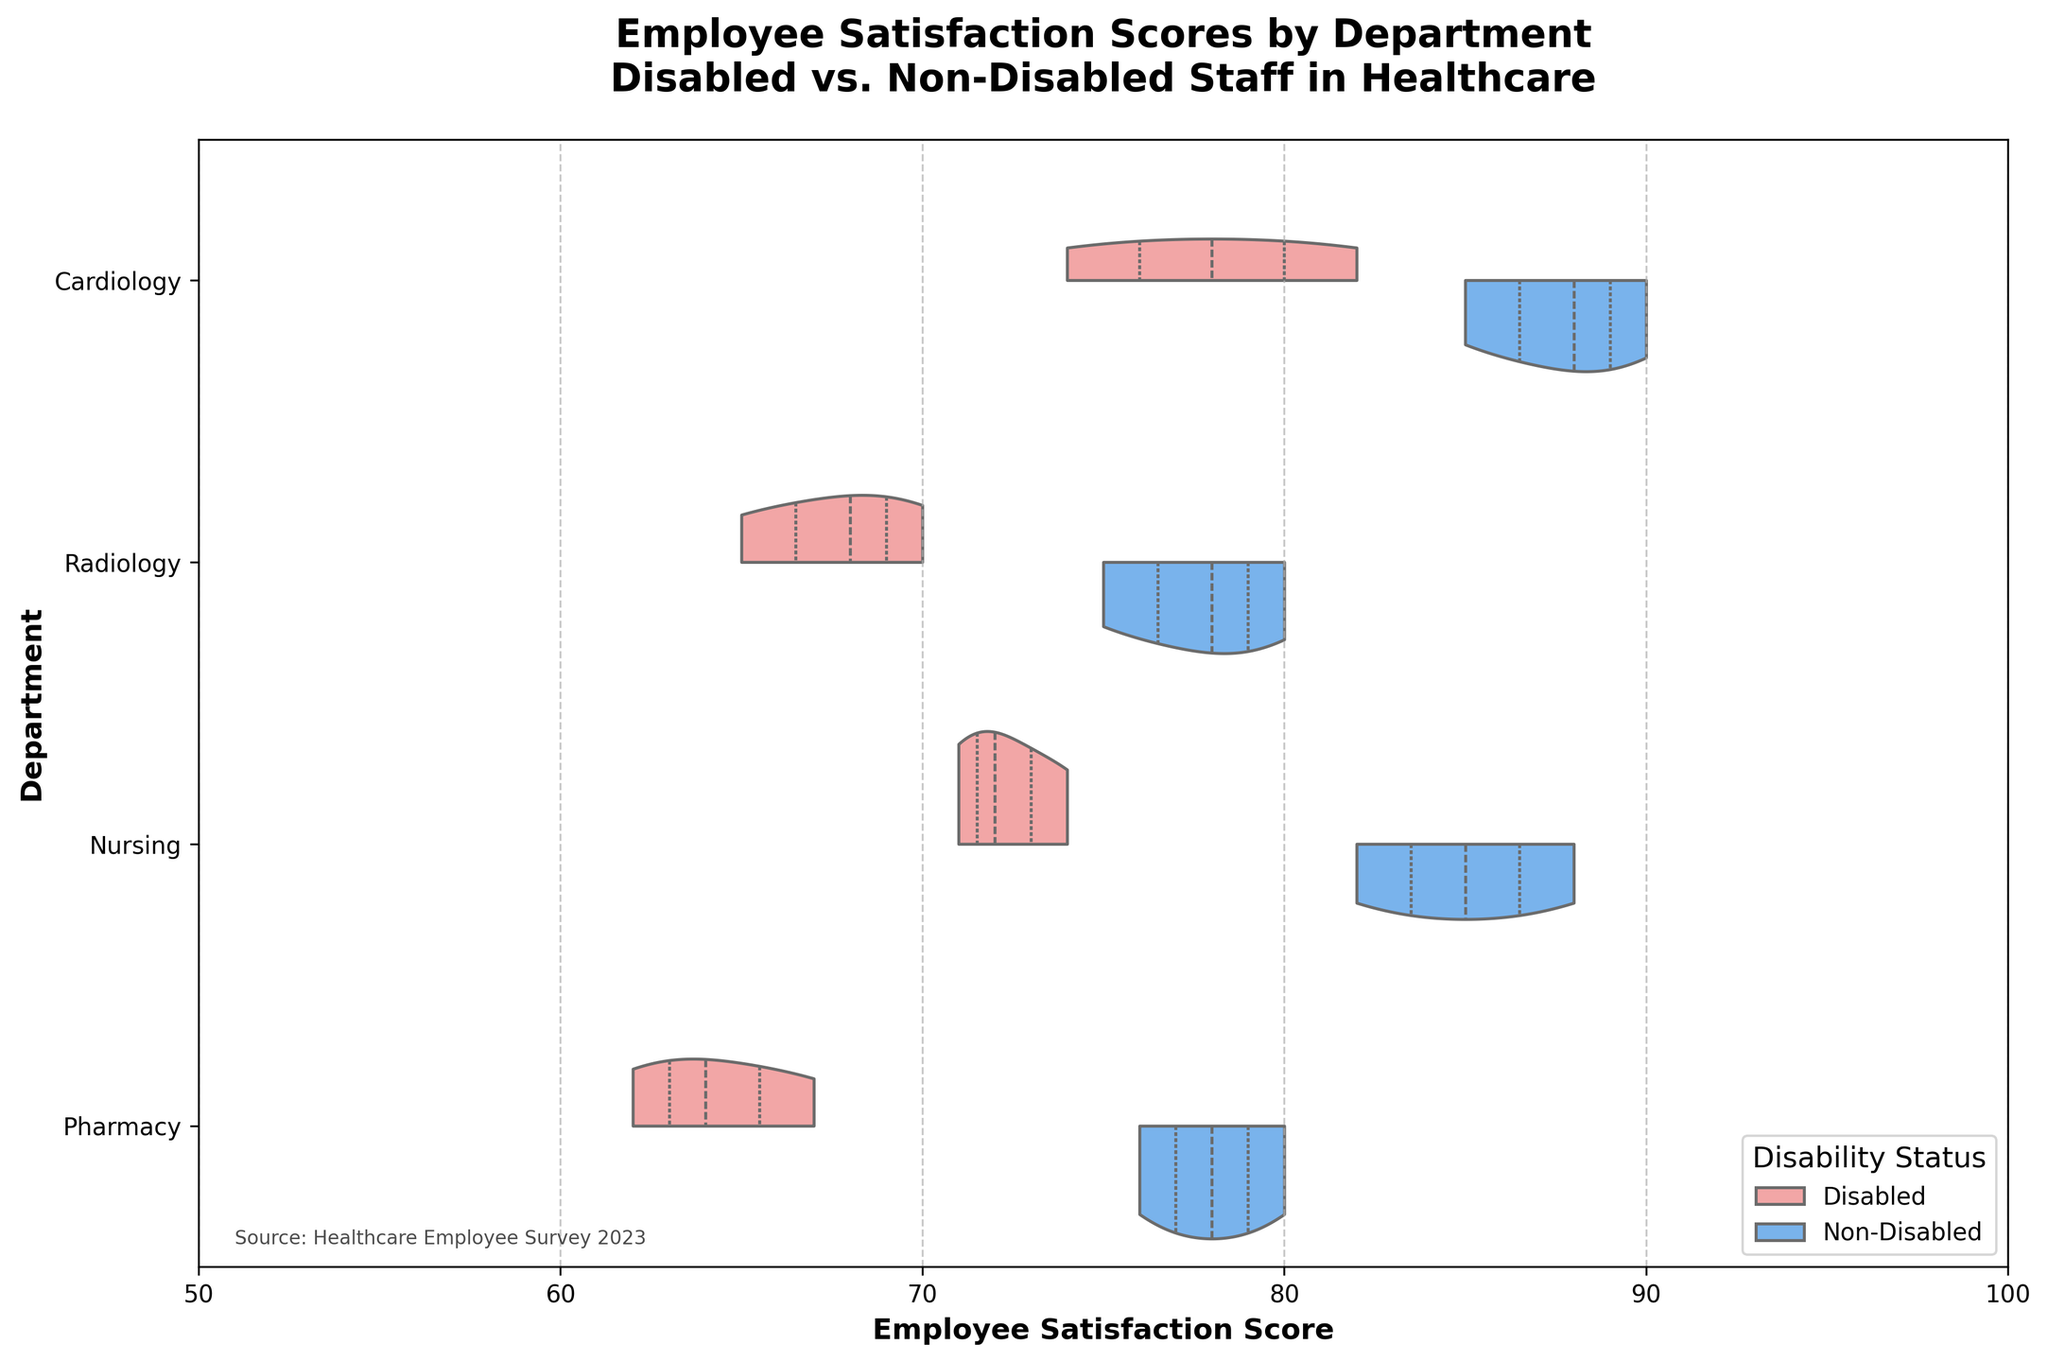What is the title of the chart? The title is positioned at the top of the chart. It reads: 'Employee Satisfaction Scores by Department\nDisabled vs. Non-Disabled Staff in Healthcare'.
Answer: 'Employee Satisfaction Scores by Department\nDisabled vs. Non-Disabled Staff in Healthcare' Which department has the highest maximum employee satisfaction score for non-disabled staff? By looking at the horizontal lines inside the violin plot, the highest point for non-disabled staff is in the Cardiology department, reaching above 90.
Answer: Cardiology Which department has a lower median employee satisfaction score for disabled staff, Radiology or Nursing? Both distributions for Radiology and Nursing represent the median as a white dot inside the distribution. The median for Radiology is around 68 and for Nursing is closer to 73.
Answer: Radiology How does the range of employee satisfaction scores for non-disabled staff in Pharmacy compare to that of disabled staff in the same department? For non-disabled staff in Pharmacy, the distribution stretches from around 76 to 80, whereas for disabled staff, it spans from around 62 to 67, showing a smaller range for non-disabled staff.
Answer: Non-disabled has a smaller range What are the colors representing the disabled and non-disabled staff in the chart? The legend in the lower right corner indicates that disabled staff is colored in light red and non-disabled staff in light blue.
Answer: Disabled: light red; Non-Disabled: light blue Which department shows the largest spread in employee satisfaction scores for disabled staff? By inspecting the width of the violin plots, Pharmacy has the widest spread in scores for disabled staff since the distribution is widest and covers the largest range on the satisfaction score axis.
Answer: Pharmacy What is the general trend in employee satisfaction scores for non-disabled staff across all departments? By observing the positions of the blue distributions, non-disabled staff show generally higher satisfaction scores across all departments, staying well above 70 and reaching into the 80s and 90s.
Answer: Higher satisfaction scores What is the approximate median employee satisfaction score for non-disabled staff in Radiology? The median is represented by the white dot within the blue distribution of Radiology. It appears to be around 78.
Answer: 78 Which department shows a higher difference in median employee satisfaction scores between disabled and non-disabled staff? The median scores are represented by the white dots within each distribution; Cardiology shows the most noticeable gap, with disabled staff around 78 and non-disabled well above 85.
Answer: Cardiology What is the maximal score represented on the x-axis? By looking at the x-axis, the maximal score is marked at 100.
Answer: 100 